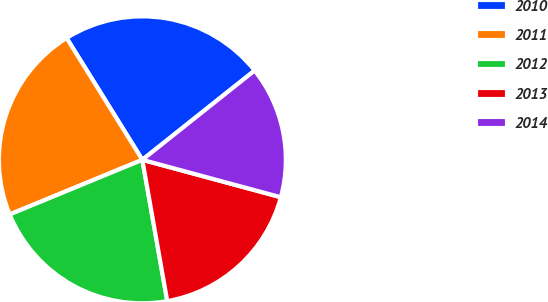<chart> <loc_0><loc_0><loc_500><loc_500><pie_chart><fcel>2010<fcel>2011<fcel>2012<fcel>2013<fcel>2014<nl><fcel>23.16%<fcel>22.36%<fcel>21.56%<fcel>18.02%<fcel>14.89%<nl></chart> 